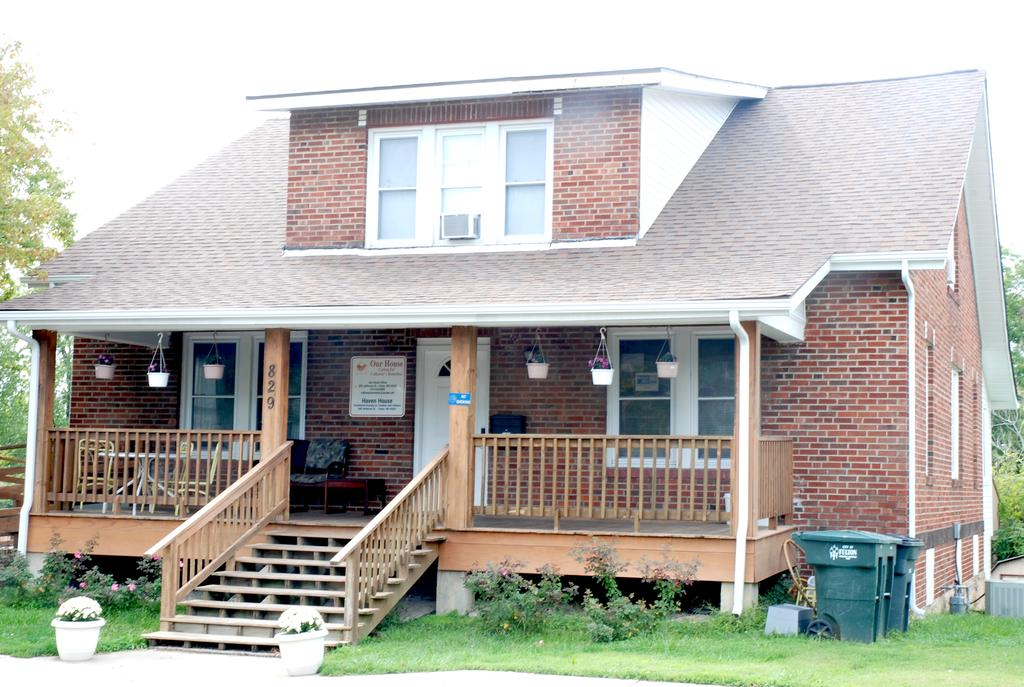What type of landscape is depicted in the image? There is a grassland in the image. What objects can be seen on the grassland? There are dustbins and pots on the grassland. What other vegetation is present on the grassland? There are plants on the grassland. What structures can be seen in the background of the image? There is a house and trees in the background of the image. What else is visible in the background of the image? The sky is visible in the background of the image. What type of note is being passed between the trees in the image? There is no note being passed between the trees in the image; the trees are stationary and not engaged in any activity. 